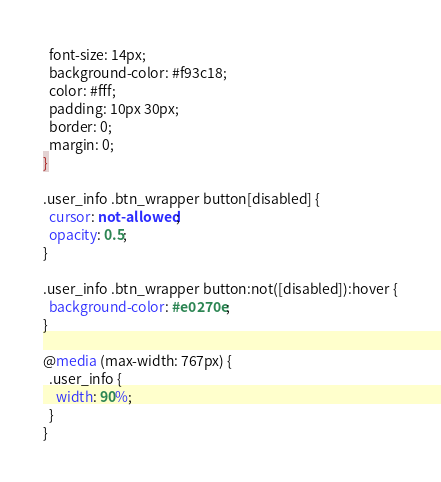<code> <loc_0><loc_0><loc_500><loc_500><_CSS_>  font-size: 14px;
  background-color: #f93c18;
  color: #fff;
  padding: 10px 30px;
  border: 0;
  margin: 0;
}

.user_info .btn_wrapper button[disabled] {
  cursor: not-allowed;
  opacity: 0.5;
}

.user_info .btn_wrapper button:not([disabled]):hover {
  background-color: #e0270e;
}

@media (max-width: 767px) {
  .user_info {
    width: 90%;
  }
}
</code> 